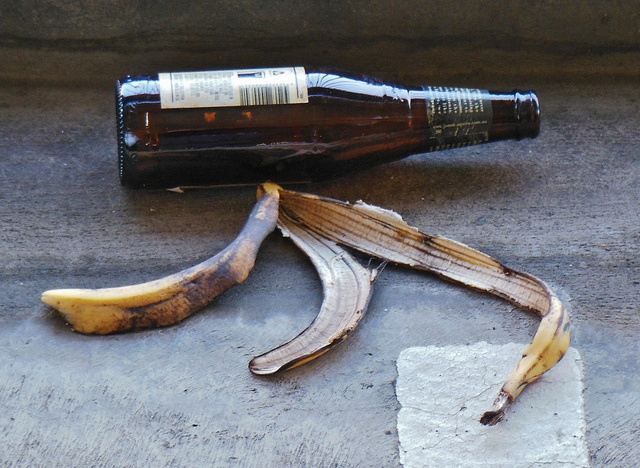Describe the objects in this image and their specific colors. I can see bottle in black, lightgray, lightblue, and maroon tones and banana in black, darkgray, lightgray, maroon, and gray tones in this image. 